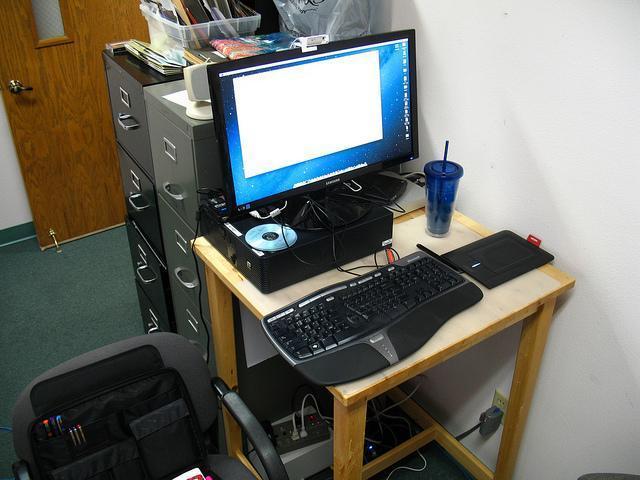How many people are wearing cap?
Give a very brief answer. 0. 